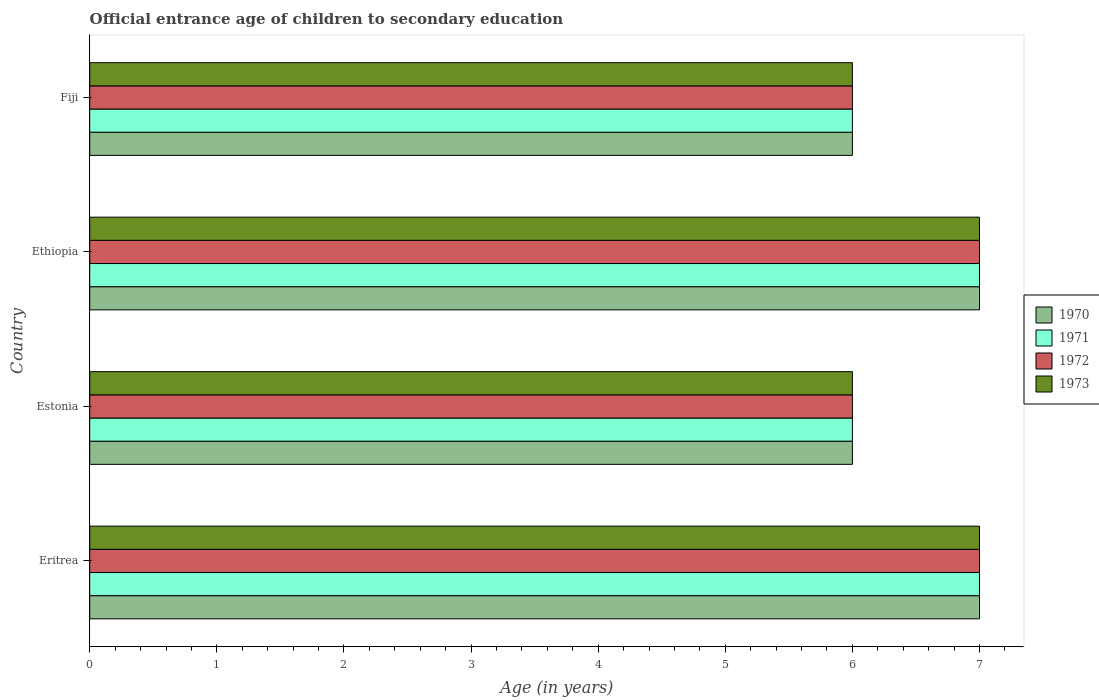How many different coloured bars are there?
Ensure brevity in your answer.  4. How many groups of bars are there?
Offer a very short reply. 4. Are the number of bars per tick equal to the number of legend labels?
Your answer should be very brief. Yes. Are the number of bars on each tick of the Y-axis equal?
Your answer should be very brief. Yes. What is the label of the 3rd group of bars from the top?
Offer a terse response. Estonia. In how many cases, is the number of bars for a given country not equal to the number of legend labels?
Your answer should be compact. 0. Across all countries, what is the minimum secondary school starting age of children in 1972?
Offer a very short reply. 6. In which country was the secondary school starting age of children in 1971 maximum?
Ensure brevity in your answer.  Eritrea. In which country was the secondary school starting age of children in 1971 minimum?
Provide a short and direct response. Estonia. What is the total secondary school starting age of children in 1973 in the graph?
Your answer should be very brief. 26. What is the difference between the secondary school starting age of children in 1971 in Fiji and the secondary school starting age of children in 1970 in Ethiopia?
Your response must be concise. -1. What is the average secondary school starting age of children in 1971 per country?
Provide a succinct answer. 6.5. What is the difference between the secondary school starting age of children in 1970 and secondary school starting age of children in 1972 in Fiji?
Offer a terse response. 0. What is the ratio of the secondary school starting age of children in 1970 in Eritrea to that in Ethiopia?
Provide a succinct answer. 1. Is the secondary school starting age of children in 1972 in Estonia less than that in Ethiopia?
Ensure brevity in your answer.  Yes. What is the difference between the highest and the second highest secondary school starting age of children in 1973?
Your answer should be compact. 0. What is the difference between the highest and the lowest secondary school starting age of children in 1973?
Keep it short and to the point. 1. In how many countries, is the secondary school starting age of children in 1970 greater than the average secondary school starting age of children in 1970 taken over all countries?
Provide a short and direct response. 2. Is it the case that in every country, the sum of the secondary school starting age of children in 1973 and secondary school starting age of children in 1970 is greater than the sum of secondary school starting age of children in 1972 and secondary school starting age of children in 1971?
Provide a short and direct response. No. Is it the case that in every country, the sum of the secondary school starting age of children in 1973 and secondary school starting age of children in 1971 is greater than the secondary school starting age of children in 1970?
Provide a succinct answer. Yes. Are all the bars in the graph horizontal?
Give a very brief answer. Yes. How many countries are there in the graph?
Offer a very short reply. 4. Does the graph contain any zero values?
Offer a terse response. No. Does the graph contain grids?
Offer a terse response. No. Where does the legend appear in the graph?
Keep it short and to the point. Center right. How many legend labels are there?
Your response must be concise. 4. What is the title of the graph?
Ensure brevity in your answer.  Official entrance age of children to secondary education. What is the label or title of the X-axis?
Your answer should be compact. Age (in years). What is the label or title of the Y-axis?
Offer a terse response. Country. What is the Age (in years) of 1972 in Eritrea?
Give a very brief answer. 7. What is the Age (in years) of 1972 in Estonia?
Provide a short and direct response. 6. What is the Age (in years) of 1973 in Estonia?
Offer a terse response. 6. What is the Age (in years) in 1970 in Ethiopia?
Your response must be concise. 7. What is the Age (in years) of 1972 in Ethiopia?
Provide a succinct answer. 7. Across all countries, what is the minimum Age (in years) in 1970?
Your answer should be very brief. 6. Across all countries, what is the minimum Age (in years) of 1973?
Make the answer very short. 6. What is the total Age (in years) of 1971 in the graph?
Keep it short and to the point. 26. What is the total Age (in years) of 1972 in the graph?
Provide a short and direct response. 26. What is the difference between the Age (in years) of 1970 in Eritrea and that in Estonia?
Offer a terse response. 1. What is the difference between the Age (in years) of 1972 in Eritrea and that in Estonia?
Your response must be concise. 1. What is the difference between the Age (in years) of 1973 in Eritrea and that in Estonia?
Offer a very short reply. 1. What is the difference between the Age (in years) in 1970 in Eritrea and that in Ethiopia?
Offer a terse response. 0. What is the difference between the Age (in years) in 1971 in Eritrea and that in Ethiopia?
Your response must be concise. 0. What is the difference between the Age (in years) in 1972 in Eritrea and that in Ethiopia?
Give a very brief answer. 0. What is the difference between the Age (in years) of 1973 in Eritrea and that in Ethiopia?
Provide a succinct answer. 0. What is the difference between the Age (in years) in 1970 in Eritrea and that in Fiji?
Provide a succinct answer. 1. What is the difference between the Age (in years) in 1971 in Eritrea and that in Fiji?
Give a very brief answer. 1. What is the difference between the Age (in years) in 1973 in Eritrea and that in Fiji?
Your answer should be compact. 1. What is the difference between the Age (in years) of 1971 in Estonia and that in Ethiopia?
Offer a very short reply. -1. What is the difference between the Age (in years) in 1972 in Estonia and that in Ethiopia?
Provide a short and direct response. -1. What is the difference between the Age (in years) of 1970 in Estonia and that in Fiji?
Your answer should be compact. 0. What is the difference between the Age (in years) of 1971 in Estonia and that in Fiji?
Provide a short and direct response. 0. What is the difference between the Age (in years) in 1970 in Ethiopia and that in Fiji?
Give a very brief answer. 1. What is the difference between the Age (in years) of 1971 in Ethiopia and that in Fiji?
Give a very brief answer. 1. What is the difference between the Age (in years) of 1970 in Eritrea and the Age (in years) of 1971 in Estonia?
Give a very brief answer. 1. What is the difference between the Age (in years) in 1971 in Eritrea and the Age (in years) in 1973 in Estonia?
Make the answer very short. 1. What is the difference between the Age (in years) of 1971 in Eritrea and the Age (in years) of 1973 in Ethiopia?
Offer a very short reply. 0. What is the difference between the Age (in years) of 1972 in Eritrea and the Age (in years) of 1973 in Ethiopia?
Give a very brief answer. 0. What is the difference between the Age (in years) in 1970 in Eritrea and the Age (in years) in 1971 in Fiji?
Offer a very short reply. 1. What is the difference between the Age (in years) of 1970 in Eritrea and the Age (in years) of 1973 in Fiji?
Provide a succinct answer. 1. What is the difference between the Age (in years) in 1971 in Eritrea and the Age (in years) in 1972 in Fiji?
Your answer should be compact. 1. What is the difference between the Age (in years) of 1970 in Estonia and the Age (in years) of 1971 in Ethiopia?
Offer a terse response. -1. What is the difference between the Age (in years) in 1971 in Estonia and the Age (in years) in 1972 in Ethiopia?
Provide a short and direct response. -1. What is the difference between the Age (in years) in 1971 in Estonia and the Age (in years) in 1973 in Ethiopia?
Your response must be concise. -1. What is the difference between the Age (in years) in 1972 in Estonia and the Age (in years) in 1973 in Ethiopia?
Provide a succinct answer. -1. What is the difference between the Age (in years) of 1970 in Estonia and the Age (in years) of 1971 in Fiji?
Keep it short and to the point. 0. What is the difference between the Age (in years) of 1970 in Estonia and the Age (in years) of 1972 in Fiji?
Provide a short and direct response. 0. What is the difference between the Age (in years) of 1970 in Ethiopia and the Age (in years) of 1972 in Fiji?
Your answer should be very brief. 1. What is the difference between the Age (in years) of 1970 in Ethiopia and the Age (in years) of 1973 in Fiji?
Offer a very short reply. 1. What is the difference between the Age (in years) of 1971 in Ethiopia and the Age (in years) of 1973 in Fiji?
Offer a terse response. 1. What is the average Age (in years) in 1971 per country?
Offer a terse response. 6.5. What is the average Age (in years) of 1972 per country?
Give a very brief answer. 6.5. What is the average Age (in years) of 1973 per country?
Make the answer very short. 6.5. What is the difference between the Age (in years) of 1970 and Age (in years) of 1971 in Eritrea?
Your response must be concise. 0. What is the difference between the Age (in years) of 1970 and Age (in years) of 1973 in Eritrea?
Give a very brief answer. 0. What is the difference between the Age (in years) of 1971 and Age (in years) of 1972 in Eritrea?
Your answer should be very brief. 0. What is the difference between the Age (in years) of 1970 and Age (in years) of 1971 in Estonia?
Offer a terse response. 0. What is the difference between the Age (in years) in 1970 and Age (in years) in 1972 in Estonia?
Provide a succinct answer. 0. What is the difference between the Age (in years) of 1970 and Age (in years) of 1973 in Estonia?
Ensure brevity in your answer.  0. What is the difference between the Age (in years) in 1971 and Age (in years) in 1972 in Estonia?
Your answer should be very brief. 0. What is the difference between the Age (in years) in 1970 and Age (in years) in 1973 in Ethiopia?
Your response must be concise. 0. What is the difference between the Age (in years) in 1971 and Age (in years) in 1972 in Ethiopia?
Provide a succinct answer. 0. What is the difference between the Age (in years) in 1971 and Age (in years) in 1973 in Ethiopia?
Offer a terse response. 0. What is the difference between the Age (in years) of 1970 and Age (in years) of 1972 in Fiji?
Make the answer very short. 0. What is the ratio of the Age (in years) of 1972 in Eritrea to that in Estonia?
Ensure brevity in your answer.  1.17. What is the ratio of the Age (in years) in 1973 in Eritrea to that in Estonia?
Your answer should be compact. 1.17. What is the ratio of the Age (in years) of 1973 in Eritrea to that in Ethiopia?
Ensure brevity in your answer.  1. What is the ratio of the Age (in years) of 1972 in Eritrea to that in Fiji?
Your answer should be very brief. 1.17. What is the ratio of the Age (in years) of 1973 in Eritrea to that in Fiji?
Keep it short and to the point. 1.17. What is the ratio of the Age (in years) of 1971 in Estonia to that in Ethiopia?
Ensure brevity in your answer.  0.86. What is the ratio of the Age (in years) of 1972 in Estonia to that in Ethiopia?
Provide a succinct answer. 0.86. What is the ratio of the Age (in years) in 1971 in Estonia to that in Fiji?
Offer a terse response. 1. What is the ratio of the Age (in years) in 1972 in Ethiopia to that in Fiji?
Offer a terse response. 1.17. What is the ratio of the Age (in years) in 1973 in Ethiopia to that in Fiji?
Give a very brief answer. 1.17. What is the difference between the highest and the second highest Age (in years) in 1971?
Your answer should be very brief. 0. What is the difference between the highest and the second highest Age (in years) of 1972?
Keep it short and to the point. 0. What is the difference between the highest and the second highest Age (in years) in 1973?
Provide a short and direct response. 0. What is the difference between the highest and the lowest Age (in years) in 1970?
Your answer should be very brief. 1. What is the difference between the highest and the lowest Age (in years) of 1971?
Your answer should be very brief. 1. What is the difference between the highest and the lowest Age (in years) in 1972?
Provide a short and direct response. 1. What is the difference between the highest and the lowest Age (in years) in 1973?
Give a very brief answer. 1. 